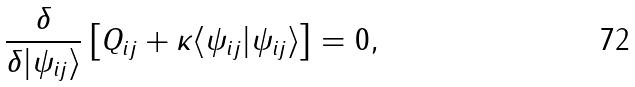<formula> <loc_0><loc_0><loc_500><loc_500>\frac { \delta } { \delta | \psi _ { i j } \rangle } \left [ Q _ { i j } + \kappa \langle \psi _ { i j } | \psi _ { i j } \rangle \right ] = 0 ,</formula> 